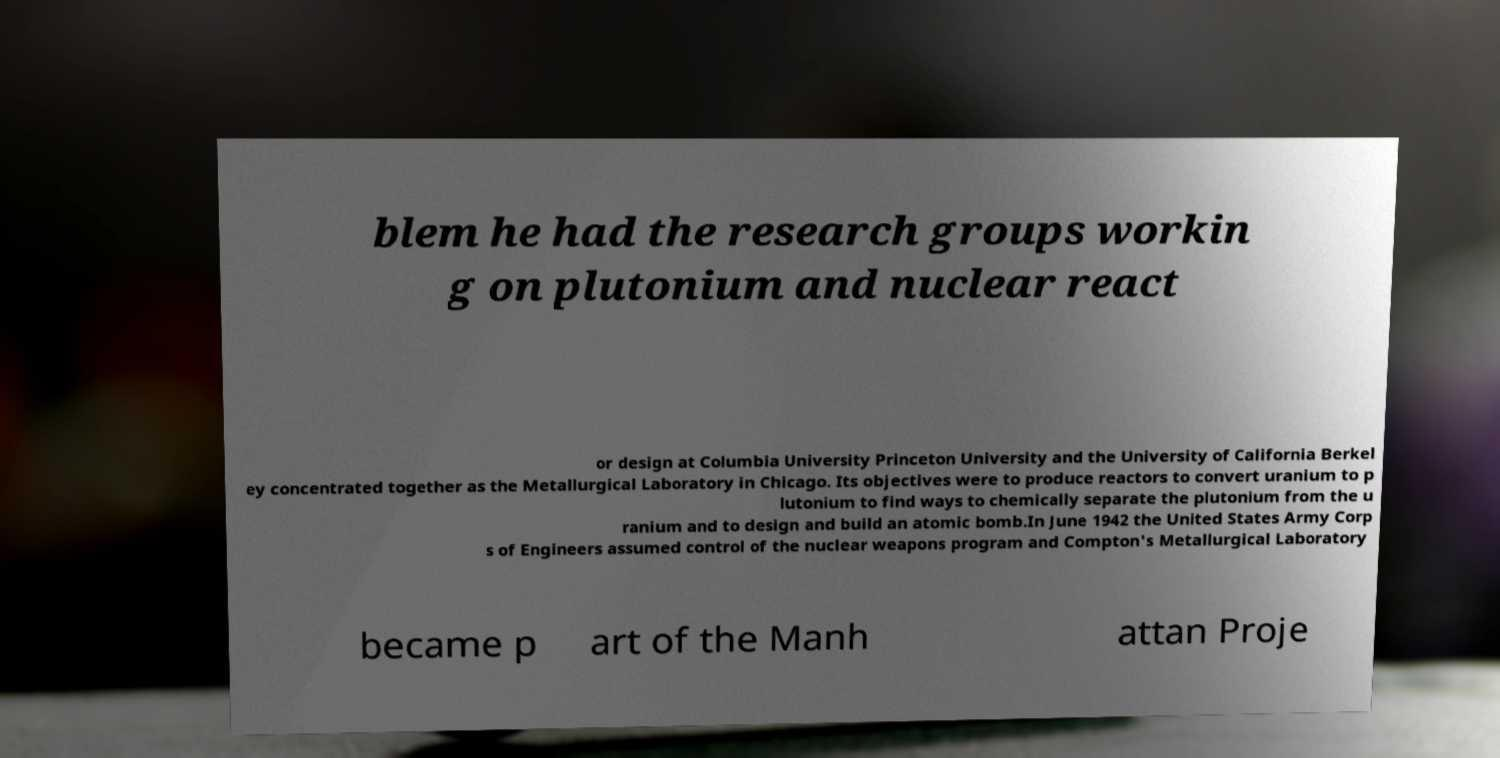There's text embedded in this image that I need extracted. Can you transcribe it verbatim? blem he had the research groups workin g on plutonium and nuclear react or design at Columbia University Princeton University and the University of California Berkel ey concentrated together as the Metallurgical Laboratory in Chicago. Its objectives were to produce reactors to convert uranium to p lutonium to find ways to chemically separate the plutonium from the u ranium and to design and build an atomic bomb.In June 1942 the United States Army Corp s of Engineers assumed control of the nuclear weapons program and Compton's Metallurgical Laboratory became p art of the Manh attan Proje 